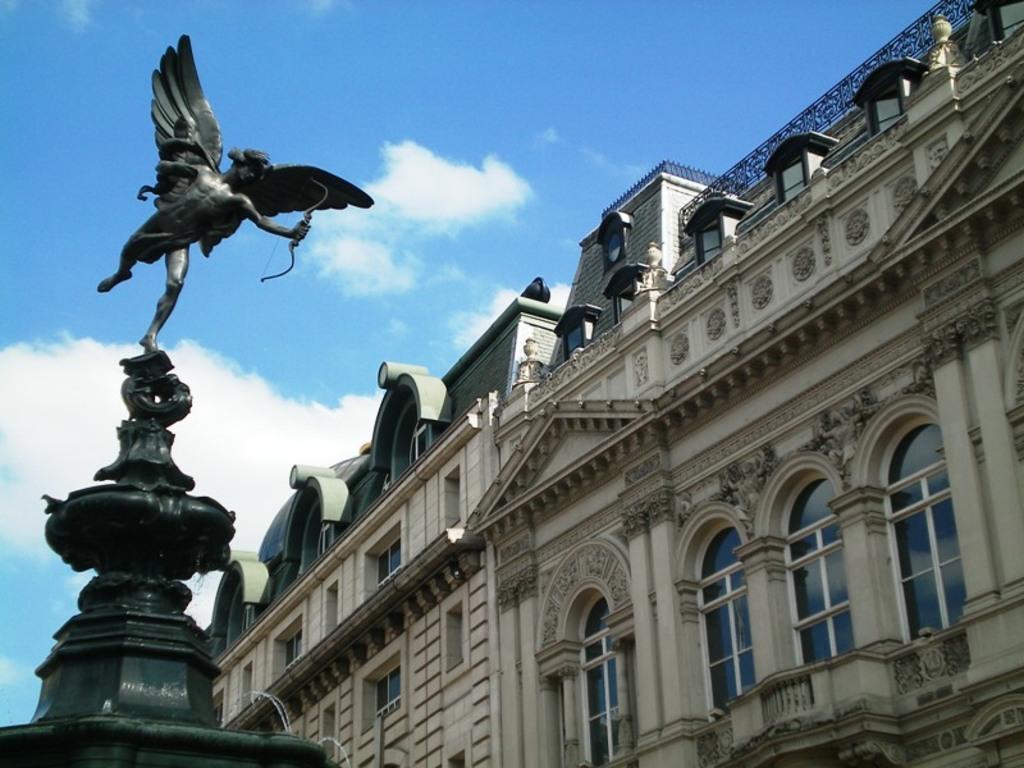Please provide a concise description of this image. In this image we can see sculpture of a human being who has wings holding archer in his hands and on right side of the image there is building, top of the image there is clear sky. 